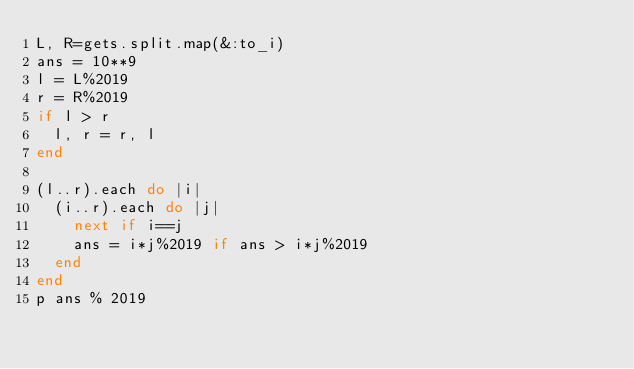Convert code to text. <code><loc_0><loc_0><loc_500><loc_500><_Ruby_>L, R=gets.split.map(&:to_i)
ans = 10**9
l = L%2019
r = R%2019
if l > r
  l, r = r, l
end

(l..r).each do |i|
  (i..r).each do |j|
    next if i==j
    ans = i*j%2019 if ans > i*j%2019
  end
end
p ans % 2019
  
</code> 